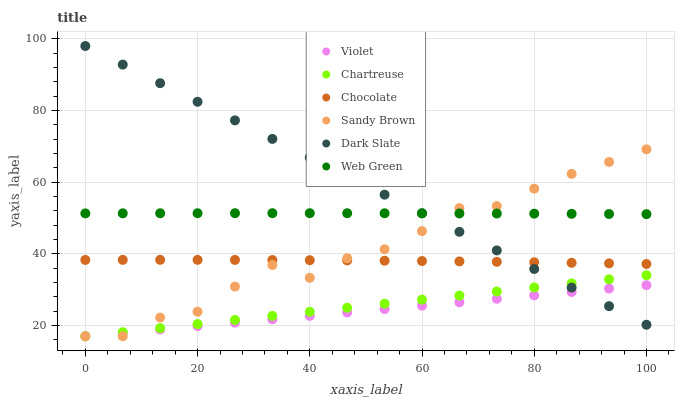Does Violet have the minimum area under the curve?
Answer yes or no. Yes. Does Dark Slate have the maximum area under the curve?
Answer yes or no. Yes. Does Chocolate have the minimum area under the curve?
Answer yes or no. No. Does Chocolate have the maximum area under the curve?
Answer yes or no. No. Is Chartreuse the smoothest?
Answer yes or no. Yes. Is Sandy Brown the roughest?
Answer yes or no. Yes. Is Chocolate the smoothest?
Answer yes or no. No. Is Chocolate the roughest?
Answer yes or no. No. Does Chartreuse have the lowest value?
Answer yes or no. Yes. Does Chocolate have the lowest value?
Answer yes or no. No. Does Dark Slate have the highest value?
Answer yes or no. Yes. Does Chocolate have the highest value?
Answer yes or no. No. Is Chartreuse less than Chocolate?
Answer yes or no. Yes. Is Web Green greater than Chocolate?
Answer yes or no. Yes. Does Sandy Brown intersect Chartreuse?
Answer yes or no. Yes. Is Sandy Brown less than Chartreuse?
Answer yes or no. No. Is Sandy Brown greater than Chartreuse?
Answer yes or no. No. Does Chartreuse intersect Chocolate?
Answer yes or no. No. 